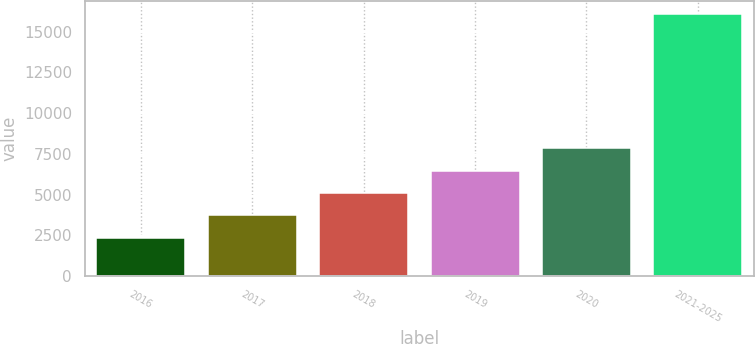Convert chart. <chart><loc_0><loc_0><loc_500><loc_500><bar_chart><fcel>2016<fcel>2017<fcel>2018<fcel>2019<fcel>2020<fcel>2021-2025<nl><fcel>2355<fcel>3724.8<fcel>5094.6<fcel>6464.4<fcel>7834.2<fcel>16053<nl></chart> 